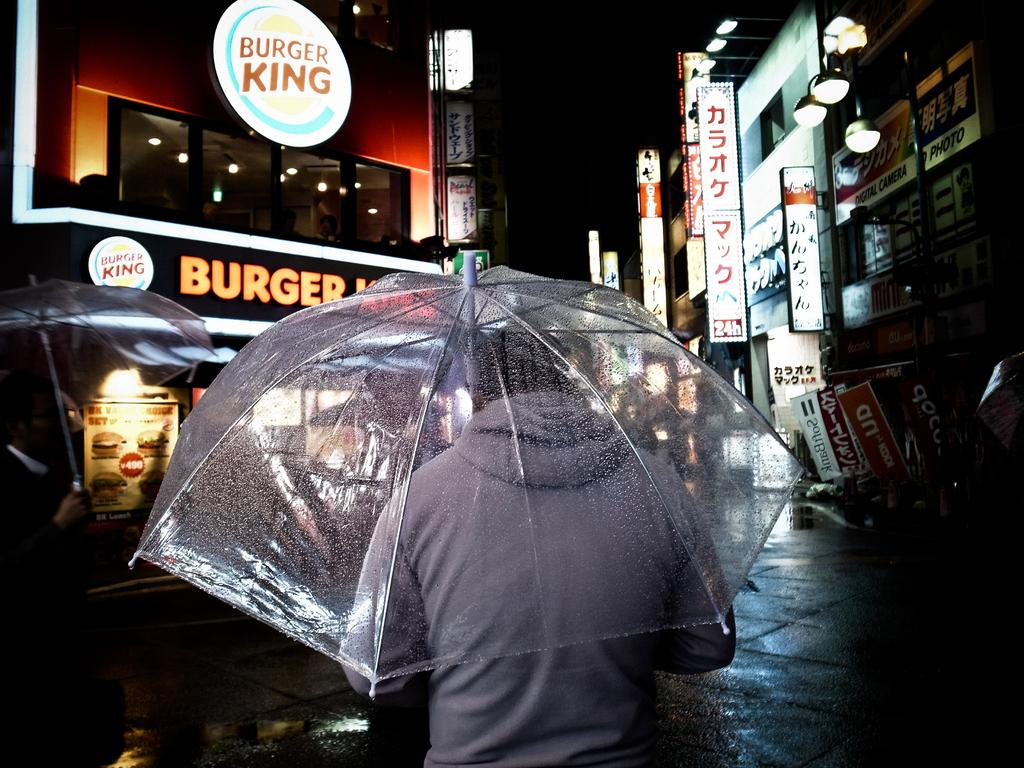What is the lighting condition in the image? The picture is taken in the dark. Despite the darkness, what can be seen in the image? There are lights visible in the image. What type of structures are present on both sides of the road? There are shops of buildings on both sides of the road. What are the people in the image using to protect themselves from the weather? People are holding umbrellas in the image. What is the weather like in the image? It appears to be raining in the image. What language is being spoken by the wall in the image? There is no wall present in the image, and therefore no language can be attributed to it. What type of vacation is being planned by the people holding umbrellas in the image? There is no indication in the image that the people holding umbrellas are planning a vacation, so it cannot be determined from the picture. 